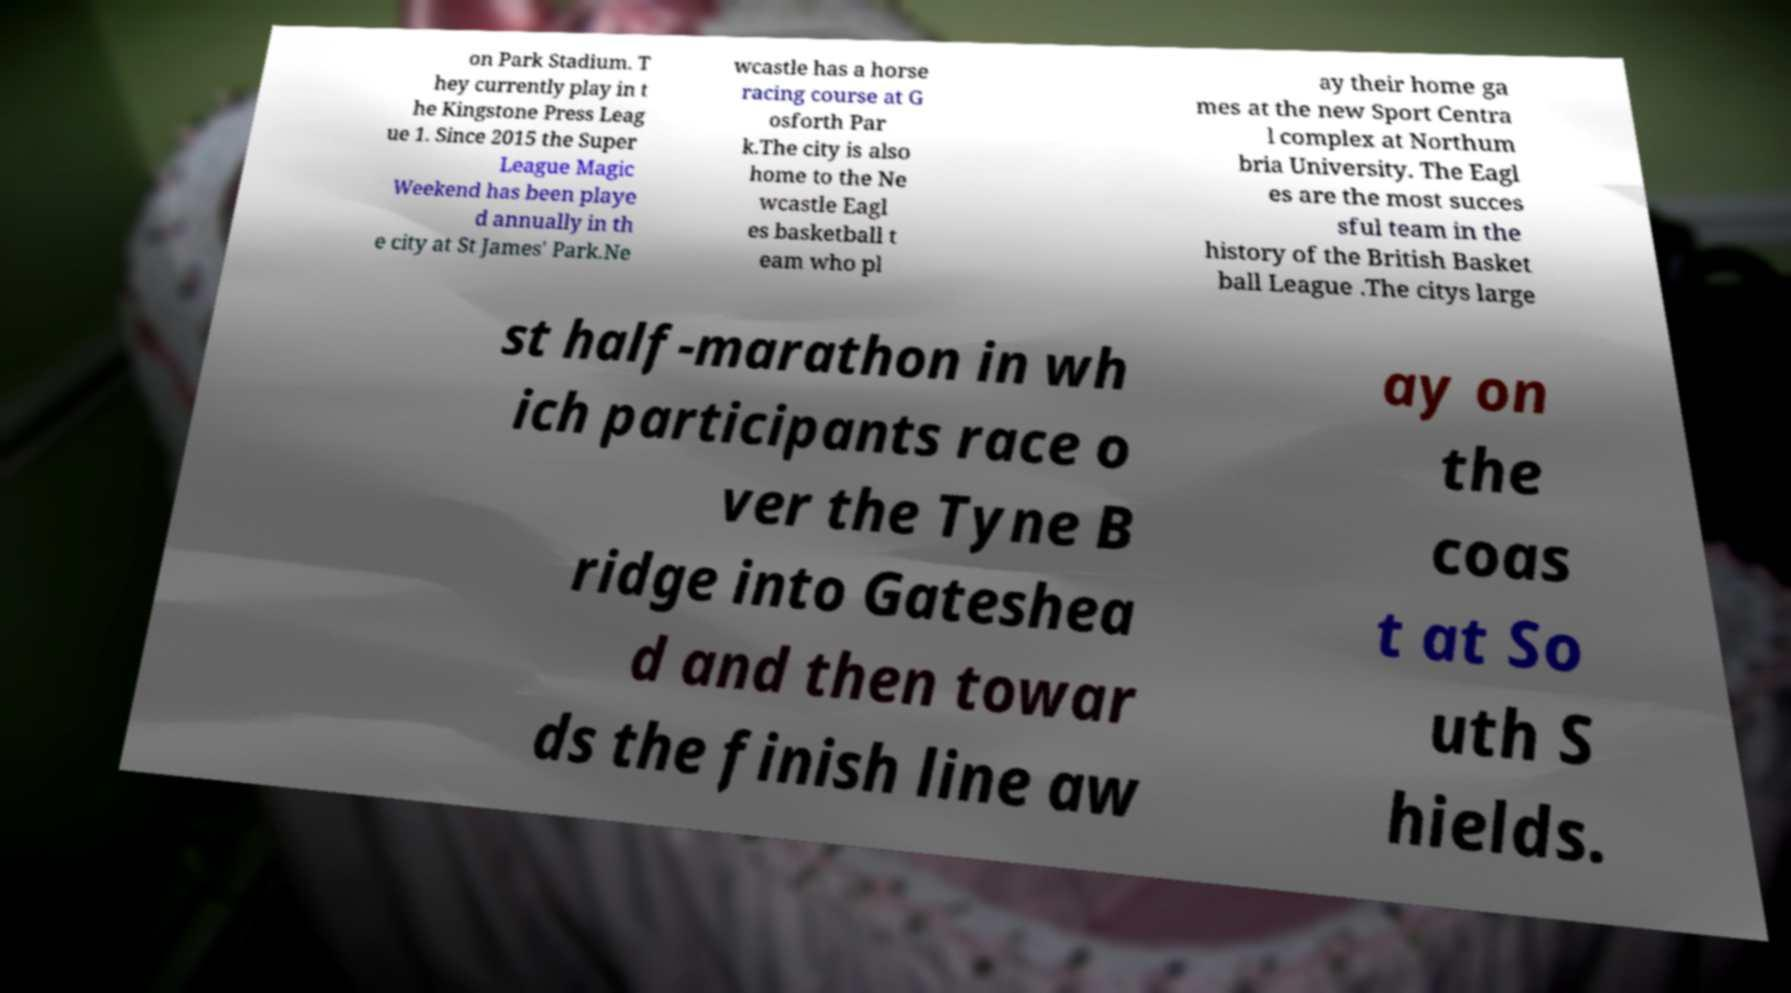For documentation purposes, I need the text within this image transcribed. Could you provide that? on Park Stadium. T hey currently play in t he Kingstone Press Leag ue 1. Since 2015 the Super League Magic Weekend has been playe d annually in th e city at St James' Park.Ne wcastle has a horse racing course at G osforth Par k.The city is also home to the Ne wcastle Eagl es basketball t eam who pl ay their home ga mes at the new Sport Centra l complex at Northum bria University. The Eagl es are the most succes sful team in the history of the British Basket ball League .The citys large st half-marathon in wh ich participants race o ver the Tyne B ridge into Gateshea d and then towar ds the finish line aw ay on the coas t at So uth S hields. 